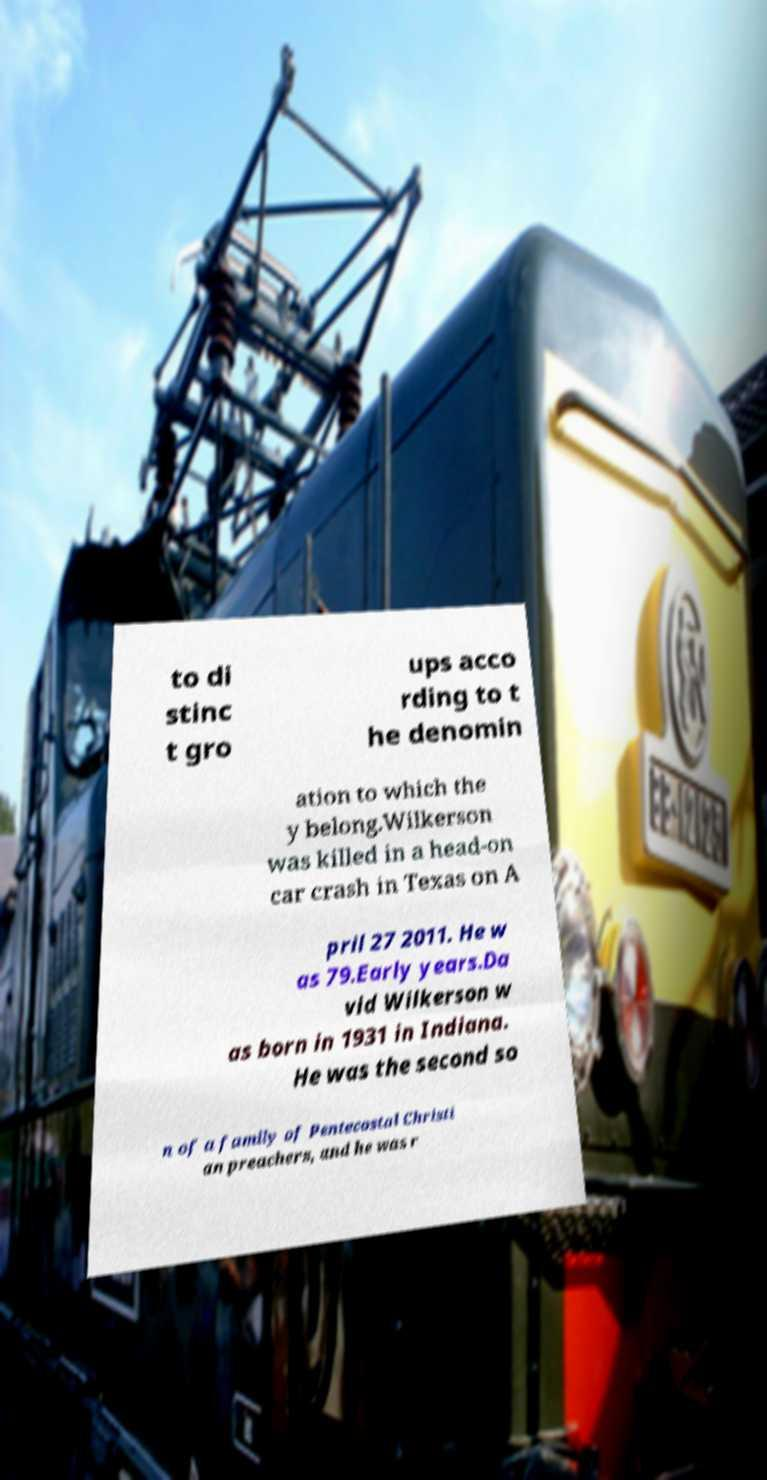Please identify and transcribe the text found in this image. to di stinc t gro ups acco rding to t he denomin ation to which the y belong.Wilkerson was killed in a head-on car crash in Texas on A pril 27 2011. He w as 79.Early years.Da vid Wilkerson w as born in 1931 in Indiana. He was the second so n of a family of Pentecostal Christi an preachers, and he was r 